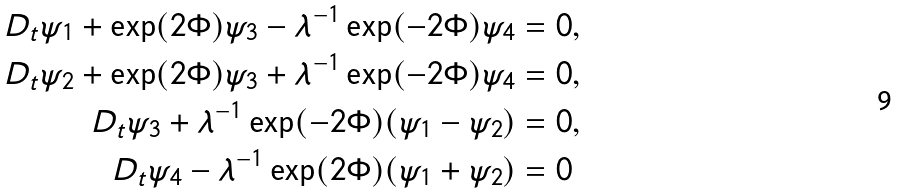<formula> <loc_0><loc_0><loc_500><loc_500>D _ { t } \psi _ { 1 } + \exp ( 2 \Phi ) \psi _ { 3 } - \lambda ^ { - 1 } \exp ( - 2 \Phi ) \psi _ { 4 } & = 0 , \\ D _ { t } \psi _ { 2 } + \exp ( 2 \Phi ) \psi _ { 3 } + \lambda ^ { - 1 } \exp ( - 2 \Phi ) \psi _ { 4 } & = 0 , \\ D _ { t } \psi _ { 3 } + \lambda ^ { - 1 } \exp ( - 2 \Phi ) ( \psi _ { 1 } - \psi _ { 2 } ) & = 0 , \\ D _ { t } \psi _ { 4 } - \lambda ^ { - 1 } \exp ( 2 \Phi ) ( \psi _ { 1 } + \psi _ { 2 } ) & = 0</formula> 